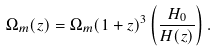<formula> <loc_0><loc_0><loc_500><loc_500>\Omega _ { m } ( z ) = \Omega _ { m } ( 1 + z ) ^ { 3 } \left ( \frac { H _ { 0 } } { H ( z ) } \right ) .</formula> 